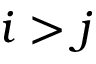Convert formula to latex. <formula><loc_0><loc_0><loc_500><loc_500>i > j</formula> 